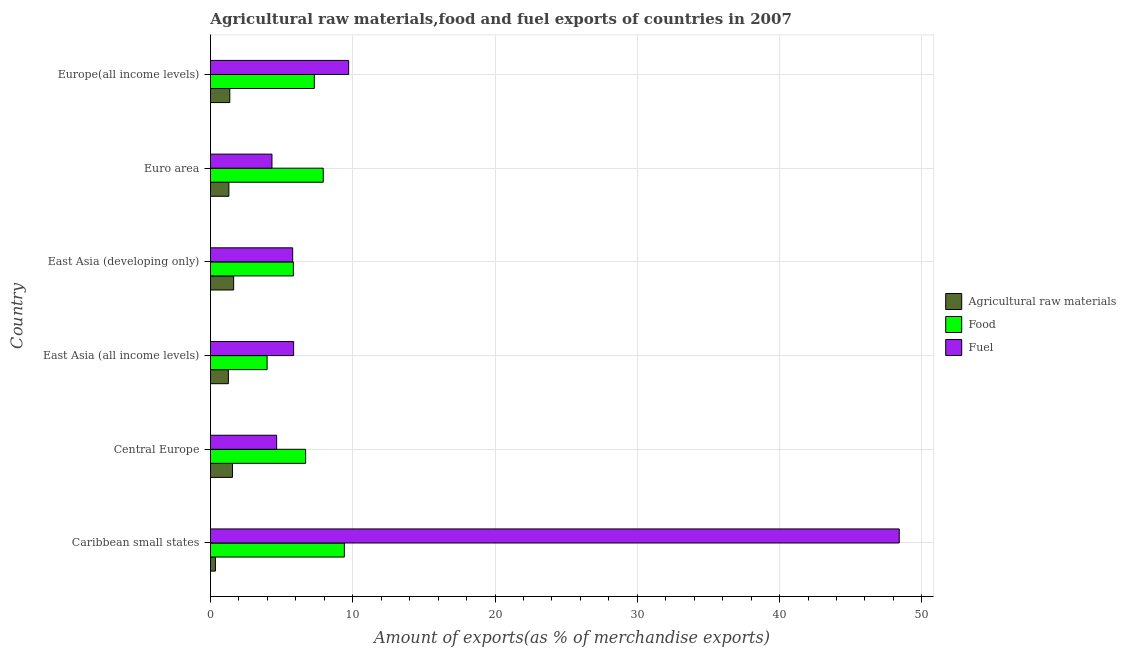How many groups of bars are there?
Make the answer very short. 6. Are the number of bars on each tick of the Y-axis equal?
Keep it short and to the point. Yes. How many bars are there on the 5th tick from the top?
Give a very brief answer. 3. How many bars are there on the 5th tick from the bottom?
Ensure brevity in your answer.  3. What is the label of the 3rd group of bars from the top?
Provide a succinct answer. East Asia (developing only). In how many cases, is the number of bars for a given country not equal to the number of legend labels?
Offer a terse response. 0. What is the percentage of raw materials exports in Europe(all income levels)?
Provide a succinct answer. 1.36. Across all countries, what is the maximum percentage of raw materials exports?
Offer a very short reply. 1.63. Across all countries, what is the minimum percentage of food exports?
Offer a terse response. 3.98. In which country was the percentage of raw materials exports maximum?
Your answer should be very brief. East Asia (developing only). In which country was the percentage of food exports minimum?
Offer a terse response. East Asia (all income levels). What is the total percentage of food exports in the graph?
Your answer should be compact. 41.13. What is the difference between the percentage of raw materials exports in East Asia (all income levels) and that in East Asia (developing only)?
Make the answer very short. -0.37. What is the difference between the percentage of food exports in Europe(all income levels) and the percentage of fuel exports in Euro area?
Your response must be concise. 2.98. What is the average percentage of food exports per country?
Ensure brevity in your answer.  6.86. What is the difference between the percentage of food exports and percentage of raw materials exports in Europe(all income levels)?
Your answer should be compact. 5.94. In how many countries, is the percentage of food exports greater than 28 %?
Provide a short and direct response. 0. What is the ratio of the percentage of fuel exports in Central Europe to that in Euro area?
Offer a terse response. 1.08. Is the percentage of raw materials exports in Caribbean small states less than that in East Asia (developing only)?
Your response must be concise. Yes. What is the difference between the highest and the second highest percentage of fuel exports?
Your answer should be compact. 38.7. What is the difference between the highest and the lowest percentage of raw materials exports?
Make the answer very short. 1.28. What does the 1st bar from the top in Euro area represents?
Provide a succinct answer. Fuel. What does the 2nd bar from the bottom in Euro area represents?
Ensure brevity in your answer.  Food. How many bars are there?
Keep it short and to the point. 18. Are all the bars in the graph horizontal?
Offer a very short reply. Yes. How many countries are there in the graph?
Offer a terse response. 6. What is the difference between two consecutive major ticks on the X-axis?
Your response must be concise. 10. Are the values on the major ticks of X-axis written in scientific E-notation?
Your answer should be very brief. No. Does the graph contain any zero values?
Give a very brief answer. No. Where does the legend appear in the graph?
Your response must be concise. Center right. How many legend labels are there?
Your response must be concise. 3. How are the legend labels stacked?
Offer a very short reply. Vertical. What is the title of the graph?
Keep it short and to the point. Agricultural raw materials,food and fuel exports of countries in 2007. Does "Infant(female)" appear as one of the legend labels in the graph?
Offer a very short reply. No. What is the label or title of the X-axis?
Offer a very short reply. Amount of exports(as % of merchandise exports). What is the Amount of exports(as % of merchandise exports) of Agricultural raw materials in Caribbean small states?
Give a very brief answer. 0.35. What is the Amount of exports(as % of merchandise exports) in Food in Caribbean small states?
Ensure brevity in your answer.  9.41. What is the Amount of exports(as % of merchandise exports) of Fuel in Caribbean small states?
Ensure brevity in your answer.  48.41. What is the Amount of exports(as % of merchandise exports) in Agricultural raw materials in Central Europe?
Offer a terse response. 1.55. What is the Amount of exports(as % of merchandise exports) of Food in Central Europe?
Offer a very short reply. 6.69. What is the Amount of exports(as % of merchandise exports) of Fuel in Central Europe?
Your answer should be compact. 4.65. What is the Amount of exports(as % of merchandise exports) of Agricultural raw materials in East Asia (all income levels)?
Offer a terse response. 1.26. What is the Amount of exports(as % of merchandise exports) of Food in East Asia (all income levels)?
Your answer should be very brief. 3.98. What is the Amount of exports(as % of merchandise exports) of Fuel in East Asia (all income levels)?
Offer a very short reply. 5.85. What is the Amount of exports(as % of merchandise exports) in Agricultural raw materials in East Asia (developing only)?
Your response must be concise. 1.63. What is the Amount of exports(as % of merchandise exports) of Food in East Asia (developing only)?
Make the answer very short. 5.83. What is the Amount of exports(as % of merchandise exports) of Fuel in East Asia (developing only)?
Provide a succinct answer. 5.78. What is the Amount of exports(as % of merchandise exports) of Agricultural raw materials in Euro area?
Your response must be concise. 1.29. What is the Amount of exports(as % of merchandise exports) of Food in Euro area?
Ensure brevity in your answer.  7.93. What is the Amount of exports(as % of merchandise exports) of Fuel in Euro area?
Provide a succinct answer. 4.32. What is the Amount of exports(as % of merchandise exports) in Agricultural raw materials in Europe(all income levels)?
Make the answer very short. 1.36. What is the Amount of exports(as % of merchandise exports) in Food in Europe(all income levels)?
Offer a terse response. 7.3. What is the Amount of exports(as % of merchandise exports) in Fuel in Europe(all income levels)?
Your response must be concise. 9.71. Across all countries, what is the maximum Amount of exports(as % of merchandise exports) in Agricultural raw materials?
Your answer should be compact. 1.63. Across all countries, what is the maximum Amount of exports(as % of merchandise exports) of Food?
Provide a short and direct response. 9.41. Across all countries, what is the maximum Amount of exports(as % of merchandise exports) in Fuel?
Give a very brief answer. 48.41. Across all countries, what is the minimum Amount of exports(as % of merchandise exports) of Agricultural raw materials?
Keep it short and to the point. 0.35. Across all countries, what is the minimum Amount of exports(as % of merchandise exports) in Food?
Offer a terse response. 3.98. Across all countries, what is the minimum Amount of exports(as % of merchandise exports) in Fuel?
Provide a short and direct response. 4.32. What is the total Amount of exports(as % of merchandise exports) of Agricultural raw materials in the graph?
Offer a very short reply. 7.43. What is the total Amount of exports(as % of merchandise exports) in Food in the graph?
Make the answer very short. 41.13. What is the total Amount of exports(as % of merchandise exports) in Fuel in the graph?
Keep it short and to the point. 78.73. What is the difference between the Amount of exports(as % of merchandise exports) of Agricultural raw materials in Caribbean small states and that in Central Europe?
Ensure brevity in your answer.  -1.2. What is the difference between the Amount of exports(as % of merchandise exports) of Food in Caribbean small states and that in Central Europe?
Give a very brief answer. 2.72. What is the difference between the Amount of exports(as % of merchandise exports) of Fuel in Caribbean small states and that in Central Europe?
Make the answer very short. 43.76. What is the difference between the Amount of exports(as % of merchandise exports) of Agricultural raw materials in Caribbean small states and that in East Asia (all income levels)?
Your answer should be compact. -0.91. What is the difference between the Amount of exports(as % of merchandise exports) in Food in Caribbean small states and that in East Asia (all income levels)?
Provide a succinct answer. 5.43. What is the difference between the Amount of exports(as % of merchandise exports) in Fuel in Caribbean small states and that in East Asia (all income levels)?
Provide a succinct answer. 42.57. What is the difference between the Amount of exports(as % of merchandise exports) of Agricultural raw materials in Caribbean small states and that in East Asia (developing only)?
Give a very brief answer. -1.28. What is the difference between the Amount of exports(as % of merchandise exports) of Food in Caribbean small states and that in East Asia (developing only)?
Give a very brief answer. 3.58. What is the difference between the Amount of exports(as % of merchandise exports) in Fuel in Caribbean small states and that in East Asia (developing only)?
Keep it short and to the point. 42.64. What is the difference between the Amount of exports(as % of merchandise exports) in Agricultural raw materials in Caribbean small states and that in Euro area?
Make the answer very short. -0.95. What is the difference between the Amount of exports(as % of merchandise exports) of Food in Caribbean small states and that in Euro area?
Offer a very short reply. 1.48. What is the difference between the Amount of exports(as % of merchandise exports) in Fuel in Caribbean small states and that in Euro area?
Make the answer very short. 44.09. What is the difference between the Amount of exports(as % of merchandise exports) in Agricultural raw materials in Caribbean small states and that in Europe(all income levels)?
Provide a succinct answer. -1.01. What is the difference between the Amount of exports(as % of merchandise exports) of Food in Caribbean small states and that in Europe(all income levels)?
Make the answer very short. 2.11. What is the difference between the Amount of exports(as % of merchandise exports) of Fuel in Caribbean small states and that in Europe(all income levels)?
Provide a short and direct response. 38.7. What is the difference between the Amount of exports(as % of merchandise exports) in Agricultural raw materials in Central Europe and that in East Asia (all income levels)?
Your response must be concise. 0.29. What is the difference between the Amount of exports(as % of merchandise exports) of Food in Central Europe and that in East Asia (all income levels)?
Ensure brevity in your answer.  2.71. What is the difference between the Amount of exports(as % of merchandise exports) in Fuel in Central Europe and that in East Asia (all income levels)?
Your response must be concise. -1.19. What is the difference between the Amount of exports(as % of merchandise exports) of Agricultural raw materials in Central Europe and that in East Asia (developing only)?
Provide a short and direct response. -0.08. What is the difference between the Amount of exports(as % of merchandise exports) of Food in Central Europe and that in East Asia (developing only)?
Give a very brief answer. 0.86. What is the difference between the Amount of exports(as % of merchandise exports) of Fuel in Central Europe and that in East Asia (developing only)?
Ensure brevity in your answer.  -1.13. What is the difference between the Amount of exports(as % of merchandise exports) of Agricultural raw materials in Central Europe and that in Euro area?
Provide a short and direct response. 0.25. What is the difference between the Amount of exports(as % of merchandise exports) of Food in Central Europe and that in Euro area?
Keep it short and to the point. -1.24. What is the difference between the Amount of exports(as % of merchandise exports) of Fuel in Central Europe and that in Euro area?
Provide a short and direct response. 0.33. What is the difference between the Amount of exports(as % of merchandise exports) of Agricultural raw materials in Central Europe and that in Europe(all income levels)?
Keep it short and to the point. 0.19. What is the difference between the Amount of exports(as % of merchandise exports) in Food in Central Europe and that in Europe(all income levels)?
Provide a short and direct response. -0.61. What is the difference between the Amount of exports(as % of merchandise exports) of Fuel in Central Europe and that in Europe(all income levels)?
Give a very brief answer. -5.06. What is the difference between the Amount of exports(as % of merchandise exports) of Agricultural raw materials in East Asia (all income levels) and that in East Asia (developing only)?
Provide a short and direct response. -0.37. What is the difference between the Amount of exports(as % of merchandise exports) in Food in East Asia (all income levels) and that in East Asia (developing only)?
Provide a short and direct response. -1.85. What is the difference between the Amount of exports(as % of merchandise exports) in Fuel in East Asia (all income levels) and that in East Asia (developing only)?
Give a very brief answer. 0.07. What is the difference between the Amount of exports(as % of merchandise exports) of Agricultural raw materials in East Asia (all income levels) and that in Euro area?
Provide a succinct answer. -0.04. What is the difference between the Amount of exports(as % of merchandise exports) of Food in East Asia (all income levels) and that in Euro area?
Give a very brief answer. -3.95. What is the difference between the Amount of exports(as % of merchandise exports) in Fuel in East Asia (all income levels) and that in Euro area?
Offer a very short reply. 1.52. What is the difference between the Amount of exports(as % of merchandise exports) of Agricultural raw materials in East Asia (all income levels) and that in Europe(all income levels)?
Give a very brief answer. -0.1. What is the difference between the Amount of exports(as % of merchandise exports) in Food in East Asia (all income levels) and that in Europe(all income levels)?
Keep it short and to the point. -3.32. What is the difference between the Amount of exports(as % of merchandise exports) of Fuel in East Asia (all income levels) and that in Europe(all income levels)?
Provide a short and direct response. -3.87. What is the difference between the Amount of exports(as % of merchandise exports) of Agricultural raw materials in East Asia (developing only) and that in Euro area?
Your response must be concise. 0.34. What is the difference between the Amount of exports(as % of merchandise exports) in Food in East Asia (developing only) and that in Euro area?
Provide a succinct answer. -2.1. What is the difference between the Amount of exports(as % of merchandise exports) in Fuel in East Asia (developing only) and that in Euro area?
Ensure brevity in your answer.  1.46. What is the difference between the Amount of exports(as % of merchandise exports) of Agricultural raw materials in East Asia (developing only) and that in Europe(all income levels)?
Offer a terse response. 0.27. What is the difference between the Amount of exports(as % of merchandise exports) in Food in East Asia (developing only) and that in Europe(all income levels)?
Offer a very short reply. -1.47. What is the difference between the Amount of exports(as % of merchandise exports) of Fuel in East Asia (developing only) and that in Europe(all income levels)?
Ensure brevity in your answer.  -3.93. What is the difference between the Amount of exports(as % of merchandise exports) of Agricultural raw materials in Euro area and that in Europe(all income levels)?
Offer a very short reply. -0.07. What is the difference between the Amount of exports(as % of merchandise exports) of Food in Euro area and that in Europe(all income levels)?
Give a very brief answer. 0.63. What is the difference between the Amount of exports(as % of merchandise exports) in Fuel in Euro area and that in Europe(all income levels)?
Your answer should be very brief. -5.39. What is the difference between the Amount of exports(as % of merchandise exports) in Agricultural raw materials in Caribbean small states and the Amount of exports(as % of merchandise exports) in Food in Central Europe?
Make the answer very short. -6.34. What is the difference between the Amount of exports(as % of merchandise exports) of Agricultural raw materials in Caribbean small states and the Amount of exports(as % of merchandise exports) of Fuel in Central Europe?
Provide a short and direct response. -4.3. What is the difference between the Amount of exports(as % of merchandise exports) in Food in Caribbean small states and the Amount of exports(as % of merchandise exports) in Fuel in Central Europe?
Your answer should be very brief. 4.76. What is the difference between the Amount of exports(as % of merchandise exports) of Agricultural raw materials in Caribbean small states and the Amount of exports(as % of merchandise exports) of Food in East Asia (all income levels)?
Give a very brief answer. -3.63. What is the difference between the Amount of exports(as % of merchandise exports) in Agricultural raw materials in Caribbean small states and the Amount of exports(as % of merchandise exports) in Fuel in East Asia (all income levels)?
Give a very brief answer. -5.5. What is the difference between the Amount of exports(as % of merchandise exports) in Food in Caribbean small states and the Amount of exports(as % of merchandise exports) in Fuel in East Asia (all income levels)?
Provide a short and direct response. 3.56. What is the difference between the Amount of exports(as % of merchandise exports) in Agricultural raw materials in Caribbean small states and the Amount of exports(as % of merchandise exports) in Food in East Asia (developing only)?
Offer a very short reply. -5.48. What is the difference between the Amount of exports(as % of merchandise exports) of Agricultural raw materials in Caribbean small states and the Amount of exports(as % of merchandise exports) of Fuel in East Asia (developing only)?
Provide a short and direct response. -5.43. What is the difference between the Amount of exports(as % of merchandise exports) of Food in Caribbean small states and the Amount of exports(as % of merchandise exports) of Fuel in East Asia (developing only)?
Provide a succinct answer. 3.63. What is the difference between the Amount of exports(as % of merchandise exports) in Agricultural raw materials in Caribbean small states and the Amount of exports(as % of merchandise exports) in Food in Euro area?
Your answer should be compact. -7.58. What is the difference between the Amount of exports(as % of merchandise exports) in Agricultural raw materials in Caribbean small states and the Amount of exports(as % of merchandise exports) in Fuel in Euro area?
Make the answer very short. -3.97. What is the difference between the Amount of exports(as % of merchandise exports) in Food in Caribbean small states and the Amount of exports(as % of merchandise exports) in Fuel in Euro area?
Your answer should be very brief. 5.09. What is the difference between the Amount of exports(as % of merchandise exports) in Agricultural raw materials in Caribbean small states and the Amount of exports(as % of merchandise exports) in Food in Europe(all income levels)?
Provide a succinct answer. -6.95. What is the difference between the Amount of exports(as % of merchandise exports) of Agricultural raw materials in Caribbean small states and the Amount of exports(as % of merchandise exports) of Fuel in Europe(all income levels)?
Provide a short and direct response. -9.36. What is the difference between the Amount of exports(as % of merchandise exports) in Food in Caribbean small states and the Amount of exports(as % of merchandise exports) in Fuel in Europe(all income levels)?
Offer a terse response. -0.3. What is the difference between the Amount of exports(as % of merchandise exports) of Agricultural raw materials in Central Europe and the Amount of exports(as % of merchandise exports) of Food in East Asia (all income levels)?
Offer a terse response. -2.44. What is the difference between the Amount of exports(as % of merchandise exports) in Agricultural raw materials in Central Europe and the Amount of exports(as % of merchandise exports) in Fuel in East Asia (all income levels)?
Make the answer very short. -4.3. What is the difference between the Amount of exports(as % of merchandise exports) of Food in Central Europe and the Amount of exports(as % of merchandise exports) of Fuel in East Asia (all income levels)?
Your response must be concise. 0.84. What is the difference between the Amount of exports(as % of merchandise exports) in Agricultural raw materials in Central Europe and the Amount of exports(as % of merchandise exports) in Food in East Asia (developing only)?
Give a very brief answer. -4.28. What is the difference between the Amount of exports(as % of merchandise exports) of Agricultural raw materials in Central Europe and the Amount of exports(as % of merchandise exports) of Fuel in East Asia (developing only)?
Provide a succinct answer. -4.23. What is the difference between the Amount of exports(as % of merchandise exports) in Food in Central Europe and the Amount of exports(as % of merchandise exports) in Fuel in East Asia (developing only)?
Ensure brevity in your answer.  0.91. What is the difference between the Amount of exports(as % of merchandise exports) of Agricultural raw materials in Central Europe and the Amount of exports(as % of merchandise exports) of Food in Euro area?
Ensure brevity in your answer.  -6.38. What is the difference between the Amount of exports(as % of merchandise exports) of Agricultural raw materials in Central Europe and the Amount of exports(as % of merchandise exports) of Fuel in Euro area?
Keep it short and to the point. -2.78. What is the difference between the Amount of exports(as % of merchandise exports) of Food in Central Europe and the Amount of exports(as % of merchandise exports) of Fuel in Euro area?
Offer a terse response. 2.37. What is the difference between the Amount of exports(as % of merchandise exports) of Agricultural raw materials in Central Europe and the Amount of exports(as % of merchandise exports) of Food in Europe(all income levels)?
Your response must be concise. -5.75. What is the difference between the Amount of exports(as % of merchandise exports) in Agricultural raw materials in Central Europe and the Amount of exports(as % of merchandise exports) in Fuel in Europe(all income levels)?
Your answer should be compact. -8.17. What is the difference between the Amount of exports(as % of merchandise exports) in Food in Central Europe and the Amount of exports(as % of merchandise exports) in Fuel in Europe(all income levels)?
Provide a short and direct response. -3.02. What is the difference between the Amount of exports(as % of merchandise exports) of Agricultural raw materials in East Asia (all income levels) and the Amount of exports(as % of merchandise exports) of Food in East Asia (developing only)?
Provide a short and direct response. -4.57. What is the difference between the Amount of exports(as % of merchandise exports) of Agricultural raw materials in East Asia (all income levels) and the Amount of exports(as % of merchandise exports) of Fuel in East Asia (developing only)?
Ensure brevity in your answer.  -4.52. What is the difference between the Amount of exports(as % of merchandise exports) of Food in East Asia (all income levels) and the Amount of exports(as % of merchandise exports) of Fuel in East Asia (developing only)?
Provide a succinct answer. -1.8. What is the difference between the Amount of exports(as % of merchandise exports) of Agricultural raw materials in East Asia (all income levels) and the Amount of exports(as % of merchandise exports) of Food in Euro area?
Provide a succinct answer. -6.67. What is the difference between the Amount of exports(as % of merchandise exports) of Agricultural raw materials in East Asia (all income levels) and the Amount of exports(as % of merchandise exports) of Fuel in Euro area?
Make the answer very short. -3.06. What is the difference between the Amount of exports(as % of merchandise exports) in Food in East Asia (all income levels) and the Amount of exports(as % of merchandise exports) in Fuel in Euro area?
Keep it short and to the point. -0.34. What is the difference between the Amount of exports(as % of merchandise exports) of Agricultural raw materials in East Asia (all income levels) and the Amount of exports(as % of merchandise exports) of Food in Europe(all income levels)?
Your answer should be compact. -6.04. What is the difference between the Amount of exports(as % of merchandise exports) in Agricultural raw materials in East Asia (all income levels) and the Amount of exports(as % of merchandise exports) in Fuel in Europe(all income levels)?
Keep it short and to the point. -8.45. What is the difference between the Amount of exports(as % of merchandise exports) in Food in East Asia (all income levels) and the Amount of exports(as % of merchandise exports) in Fuel in Europe(all income levels)?
Ensure brevity in your answer.  -5.73. What is the difference between the Amount of exports(as % of merchandise exports) of Agricultural raw materials in East Asia (developing only) and the Amount of exports(as % of merchandise exports) of Food in Euro area?
Your response must be concise. -6.3. What is the difference between the Amount of exports(as % of merchandise exports) of Agricultural raw materials in East Asia (developing only) and the Amount of exports(as % of merchandise exports) of Fuel in Euro area?
Make the answer very short. -2.69. What is the difference between the Amount of exports(as % of merchandise exports) in Food in East Asia (developing only) and the Amount of exports(as % of merchandise exports) in Fuel in Euro area?
Your response must be concise. 1.5. What is the difference between the Amount of exports(as % of merchandise exports) in Agricultural raw materials in East Asia (developing only) and the Amount of exports(as % of merchandise exports) in Food in Europe(all income levels)?
Make the answer very short. -5.67. What is the difference between the Amount of exports(as % of merchandise exports) of Agricultural raw materials in East Asia (developing only) and the Amount of exports(as % of merchandise exports) of Fuel in Europe(all income levels)?
Give a very brief answer. -8.08. What is the difference between the Amount of exports(as % of merchandise exports) in Food in East Asia (developing only) and the Amount of exports(as % of merchandise exports) in Fuel in Europe(all income levels)?
Give a very brief answer. -3.88. What is the difference between the Amount of exports(as % of merchandise exports) of Agricultural raw materials in Euro area and the Amount of exports(as % of merchandise exports) of Food in Europe(all income levels)?
Provide a succinct answer. -6.01. What is the difference between the Amount of exports(as % of merchandise exports) of Agricultural raw materials in Euro area and the Amount of exports(as % of merchandise exports) of Fuel in Europe(all income levels)?
Your response must be concise. -8.42. What is the difference between the Amount of exports(as % of merchandise exports) in Food in Euro area and the Amount of exports(as % of merchandise exports) in Fuel in Europe(all income levels)?
Offer a terse response. -1.79. What is the average Amount of exports(as % of merchandise exports) in Agricultural raw materials per country?
Provide a succinct answer. 1.24. What is the average Amount of exports(as % of merchandise exports) in Food per country?
Keep it short and to the point. 6.86. What is the average Amount of exports(as % of merchandise exports) of Fuel per country?
Provide a short and direct response. 13.12. What is the difference between the Amount of exports(as % of merchandise exports) in Agricultural raw materials and Amount of exports(as % of merchandise exports) in Food in Caribbean small states?
Offer a very short reply. -9.06. What is the difference between the Amount of exports(as % of merchandise exports) of Agricultural raw materials and Amount of exports(as % of merchandise exports) of Fuel in Caribbean small states?
Your answer should be very brief. -48.07. What is the difference between the Amount of exports(as % of merchandise exports) of Food and Amount of exports(as % of merchandise exports) of Fuel in Caribbean small states?
Provide a short and direct response. -39. What is the difference between the Amount of exports(as % of merchandise exports) of Agricultural raw materials and Amount of exports(as % of merchandise exports) of Food in Central Europe?
Keep it short and to the point. -5.14. What is the difference between the Amount of exports(as % of merchandise exports) of Agricultural raw materials and Amount of exports(as % of merchandise exports) of Fuel in Central Europe?
Ensure brevity in your answer.  -3.11. What is the difference between the Amount of exports(as % of merchandise exports) in Food and Amount of exports(as % of merchandise exports) in Fuel in Central Europe?
Ensure brevity in your answer.  2.04. What is the difference between the Amount of exports(as % of merchandise exports) in Agricultural raw materials and Amount of exports(as % of merchandise exports) in Food in East Asia (all income levels)?
Make the answer very short. -2.72. What is the difference between the Amount of exports(as % of merchandise exports) in Agricultural raw materials and Amount of exports(as % of merchandise exports) in Fuel in East Asia (all income levels)?
Your answer should be very brief. -4.59. What is the difference between the Amount of exports(as % of merchandise exports) in Food and Amount of exports(as % of merchandise exports) in Fuel in East Asia (all income levels)?
Keep it short and to the point. -1.86. What is the difference between the Amount of exports(as % of merchandise exports) of Agricultural raw materials and Amount of exports(as % of merchandise exports) of Food in East Asia (developing only)?
Offer a very short reply. -4.2. What is the difference between the Amount of exports(as % of merchandise exports) of Agricultural raw materials and Amount of exports(as % of merchandise exports) of Fuel in East Asia (developing only)?
Make the answer very short. -4.15. What is the difference between the Amount of exports(as % of merchandise exports) of Food and Amount of exports(as % of merchandise exports) of Fuel in East Asia (developing only)?
Offer a very short reply. 0.05. What is the difference between the Amount of exports(as % of merchandise exports) of Agricultural raw materials and Amount of exports(as % of merchandise exports) of Food in Euro area?
Your answer should be compact. -6.63. What is the difference between the Amount of exports(as % of merchandise exports) in Agricultural raw materials and Amount of exports(as % of merchandise exports) in Fuel in Euro area?
Offer a very short reply. -3.03. What is the difference between the Amount of exports(as % of merchandise exports) in Food and Amount of exports(as % of merchandise exports) in Fuel in Euro area?
Your answer should be compact. 3.6. What is the difference between the Amount of exports(as % of merchandise exports) of Agricultural raw materials and Amount of exports(as % of merchandise exports) of Food in Europe(all income levels)?
Make the answer very short. -5.94. What is the difference between the Amount of exports(as % of merchandise exports) in Agricultural raw materials and Amount of exports(as % of merchandise exports) in Fuel in Europe(all income levels)?
Ensure brevity in your answer.  -8.35. What is the difference between the Amount of exports(as % of merchandise exports) of Food and Amount of exports(as % of merchandise exports) of Fuel in Europe(all income levels)?
Give a very brief answer. -2.41. What is the ratio of the Amount of exports(as % of merchandise exports) of Agricultural raw materials in Caribbean small states to that in Central Europe?
Provide a short and direct response. 0.23. What is the ratio of the Amount of exports(as % of merchandise exports) in Food in Caribbean small states to that in Central Europe?
Your answer should be compact. 1.41. What is the ratio of the Amount of exports(as % of merchandise exports) of Fuel in Caribbean small states to that in Central Europe?
Provide a short and direct response. 10.41. What is the ratio of the Amount of exports(as % of merchandise exports) of Agricultural raw materials in Caribbean small states to that in East Asia (all income levels)?
Your answer should be very brief. 0.28. What is the ratio of the Amount of exports(as % of merchandise exports) of Food in Caribbean small states to that in East Asia (all income levels)?
Ensure brevity in your answer.  2.36. What is the ratio of the Amount of exports(as % of merchandise exports) of Fuel in Caribbean small states to that in East Asia (all income levels)?
Give a very brief answer. 8.28. What is the ratio of the Amount of exports(as % of merchandise exports) in Agricultural raw materials in Caribbean small states to that in East Asia (developing only)?
Offer a terse response. 0.21. What is the ratio of the Amount of exports(as % of merchandise exports) in Food in Caribbean small states to that in East Asia (developing only)?
Your answer should be very brief. 1.61. What is the ratio of the Amount of exports(as % of merchandise exports) of Fuel in Caribbean small states to that in East Asia (developing only)?
Give a very brief answer. 8.38. What is the ratio of the Amount of exports(as % of merchandise exports) in Agricultural raw materials in Caribbean small states to that in Euro area?
Offer a terse response. 0.27. What is the ratio of the Amount of exports(as % of merchandise exports) of Food in Caribbean small states to that in Euro area?
Your response must be concise. 1.19. What is the ratio of the Amount of exports(as % of merchandise exports) in Fuel in Caribbean small states to that in Euro area?
Provide a short and direct response. 11.2. What is the ratio of the Amount of exports(as % of merchandise exports) in Agricultural raw materials in Caribbean small states to that in Europe(all income levels)?
Your answer should be very brief. 0.26. What is the ratio of the Amount of exports(as % of merchandise exports) in Food in Caribbean small states to that in Europe(all income levels)?
Make the answer very short. 1.29. What is the ratio of the Amount of exports(as % of merchandise exports) in Fuel in Caribbean small states to that in Europe(all income levels)?
Ensure brevity in your answer.  4.98. What is the ratio of the Amount of exports(as % of merchandise exports) of Agricultural raw materials in Central Europe to that in East Asia (all income levels)?
Offer a very short reply. 1.23. What is the ratio of the Amount of exports(as % of merchandise exports) of Food in Central Europe to that in East Asia (all income levels)?
Offer a very short reply. 1.68. What is the ratio of the Amount of exports(as % of merchandise exports) of Fuel in Central Europe to that in East Asia (all income levels)?
Keep it short and to the point. 0.8. What is the ratio of the Amount of exports(as % of merchandise exports) of Agricultural raw materials in Central Europe to that in East Asia (developing only)?
Offer a terse response. 0.95. What is the ratio of the Amount of exports(as % of merchandise exports) of Food in Central Europe to that in East Asia (developing only)?
Provide a succinct answer. 1.15. What is the ratio of the Amount of exports(as % of merchandise exports) in Fuel in Central Europe to that in East Asia (developing only)?
Your response must be concise. 0.81. What is the ratio of the Amount of exports(as % of merchandise exports) of Agricultural raw materials in Central Europe to that in Euro area?
Provide a succinct answer. 1.2. What is the ratio of the Amount of exports(as % of merchandise exports) of Food in Central Europe to that in Euro area?
Make the answer very short. 0.84. What is the ratio of the Amount of exports(as % of merchandise exports) in Fuel in Central Europe to that in Euro area?
Provide a succinct answer. 1.08. What is the ratio of the Amount of exports(as % of merchandise exports) in Agricultural raw materials in Central Europe to that in Europe(all income levels)?
Ensure brevity in your answer.  1.14. What is the ratio of the Amount of exports(as % of merchandise exports) in Food in Central Europe to that in Europe(all income levels)?
Keep it short and to the point. 0.92. What is the ratio of the Amount of exports(as % of merchandise exports) of Fuel in Central Europe to that in Europe(all income levels)?
Your answer should be very brief. 0.48. What is the ratio of the Amount of exports(as % of merchandise exports) in Agricultural raw materials in East Asia (all income levels) to that in East Asia (developing only)?
Provide a short and direct response. 0.77. What is the ratio of the Amount of exports(as % of merchandise exports) of Food in East Asia (all income levels) to that in East Asia (developing only)?
Your answer should be compact. 0.68. What is the ratio of the Amount of exports(as % of merchandise exports) of Fuel in East Asia (all income levels) to that in East Asia (developing only)?
Offer a very short reply. 1.01. What is the ratio of the Amount of exports(as % of merchandise exports) in Agricultural raw materials in East Asia (all income levels) to that in Euro area?
Keep it short and to the point. 0.97. What is the ratio of the Amount of exports(as % of merchandise exports) in Food in East Asia (all income levels) to that in Euro area?
Make the answer very short. 0.5. What is the ratio of the Amount of exports(as % of merchandise exports) of Fuel in East Asia (all income levels) to that in Euro area?
Make the answer very short. 1.35. What is the ratio of the Amount of exports(as % of merchandise exports) of Agricultural raw materials in East Asia (all income levels) to that in Europe(all income levels)?
Your answer should be compact. 0.93. What is the ratio of the Amount of exports(as % of merchandise exports) in Food in East Asia (all income levels) to that in Europe(all income levels)?
Your answer should be very brief. 0.55. What is the ratio of the Amount of exports(as % of merchandise exports) in Fuel in East Asia (all income levels) to that in Europe(all income levels)?
Give a very brief answer. 0.6. What is the ratio of the Amount of exports(as % of merchandise exports) of Agricultural raw materials in East Asia (developing only) to that in Euro area?
Your answer should be compact. 1.26. What is the ratio of the Amount of exports(as % of merchandise exports) of Food in East Asia (developing only) to that in Euro area?
Your answer should be very brief. 0.74. What is the ratio of the Amount of exports(as % of merchandise exports) in Fuel in East Asia (developing only) to that in Euro area?
Make the answer very short. 1.34. What is the ratio of the Amount of exports(as % of merchandise exports) in Agricultural raw materials in East Asia (developing only) to that in Europe(all income levels)?
Ensure brevity in your answer.  1.2. What is the ratio of the Amount of exports(as % of merchandise exports) in Food in East Asia (developing only) to that in Europe(all income levels)?
Your response must be concise. 0.8. What is the ratio of the Amount of exports(as % of merchandise exports) in Fuel in East Asia (developing only) to that in Europe(all income levels)?
Provide a short and direct response. 0.59. What is the ratio of the Amount of exports(as % of merchandise exports) of Agricultural raw materials in Euro area to that in Europe(all income levels)?
Your response must be concise. 0.95. What is the ratio of the Amount of exports(as % of merchandise exports) in Food in Euro area to that in Europe(all income levels)?
Your answer should be compact. 1.09. What is the ratio of the Amount of exports(as % of merchandise exports) of Fuel in Euro area to that in Europe(all income levels)?
Make the answer very short. 0.45. What is the difference between the highest and the second highest Amount of exports(as % of merchandise exports) in Agricultural raw materials?
Ensure brevity in your answer.  0.08. What is the difference between the highest and the second highest Amount of exports(as % of merchandise exports) in Food?
Make the answer very short. 1.48. What is the difference between the highest and the second highest Amount of exports(as % of merchandise exports) of Fuel?
Your answer should be compact. 38.7. What is the difference between the highest and the lowest Amount of exports(as % of merchandise exports) of Agricultural raw materials?
Provide a short and direct response. 1.28. What is the difference between the highest and the lowest Amount of exports(as % of merchandise exports) in Food?
Keep it short and to the point. 5.43. What is the difference between the highest and the lowest Amount of exports(as % of merchandise exports) of Fuel?
Ensure brevity in your answer.  44.09. 